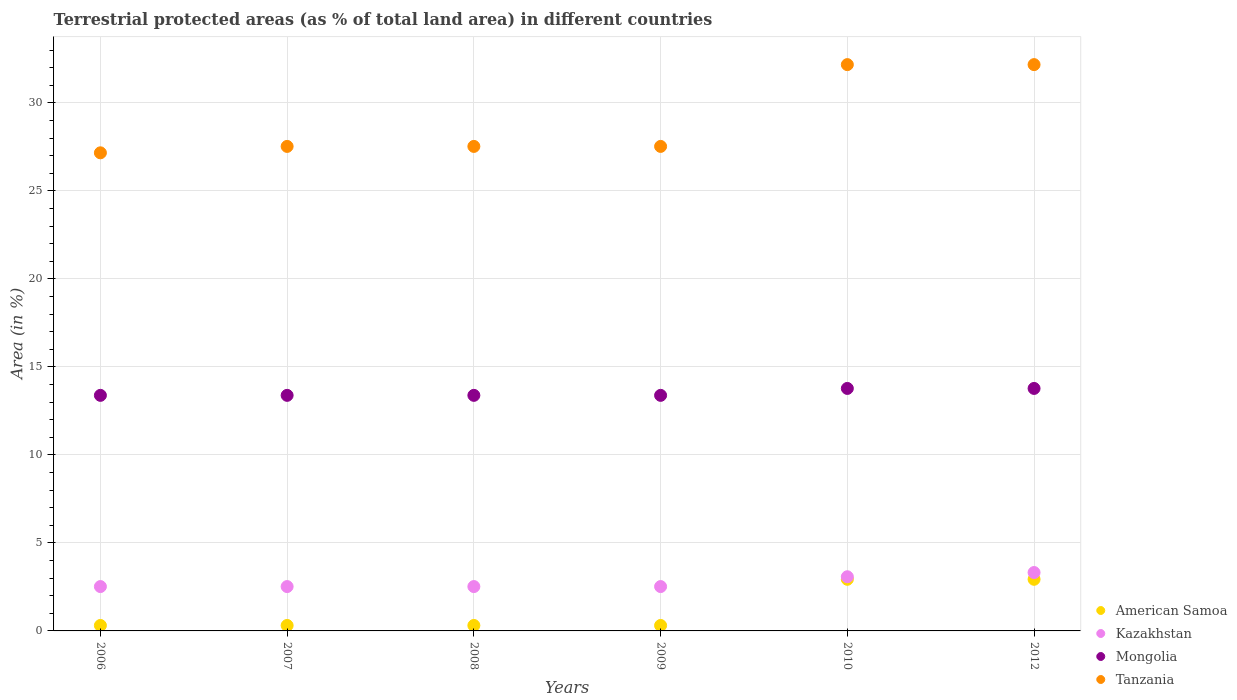How many different coloured dotlines are there?
Offer a very short reply. 4. Is the number of dotlines equal to the number of legend labels?
Your response must be concise. Yes. What is the percentage of terrestrial protected land in American Samoa in 2010?
Offer a terse response. 2.93. Across all years, what is the maximum percentage of terrestrial protected land in Mongolia?
Make the answer very short. 13.78. Across all years, what is the minimum percentage of terrestrial protected land in Kazakhstan?
Make the answer very short. 2.52. In which year was the percentage of terrestrial protected land in Tanzania maximum?
Offer a terse response. 2010. In which year was the percentage of terrestrial protected land in Mongolia minimum?
Make the answer very short. 2006. What is the total percentage of terrestrial protected land in Tanzania in the graph?
Keep it short and to the point. 174.13. What is the difference between the percentage of terrestrial protected land in American Samoa in 2006 and that in 2007?
Your answer should be compact. 0. What is the difference between the percentage of terrestrial protected land in American Samoa in 2012 and the percentage of terrestrial protected land in Mongolia in 2009?
Offer a very short reply. -10.45. What is the average percentage of terrestrial protected land in Mongolia per year?
Offer a terse response. 13.52. In the year 2008, what is the difference between the percentage of terrestrial protected land in Kazakhstan and percentage of terrestrial protected land in Mongolia?
Keep it short and to the point. -10.87. In how many years, is the percentage of terrestrial protected land in Kazakhstan greater than 3 %?
Ensure brevity in your answer.  2. Is the difference between the percentage of terrestrial protected land in Kazakhstan in 2008 and 2010 greater than the difference between the percentage of terrestrial protected land in Mongolia in 2008 and 2010?
Provide a succinct answer. No. What is the difference between the highest and the second highest percentage of terrestrial protected land in Kazakhstan?
Your response must be concise. 0.24. What is the difference between the highest and the lowest percentage of terrestrial protected land in American Samoa?
Offer a terse response. 2.62. In how many years, is the percentage of terrestrial protected land in Tanzania greater than the average percentage of terrestrial protected land in Tanzania taken over all years?
Your response must be concise. 2. Is it the case that in every year, the sum of the percentage of terrestrial protected land in Mongolia and percentage of terrestrial protected land in American Samoa  is greater than the sum of percentage of terrestrial protected land in Kazakhstan and percentage of terrestrial protected land in Tanzania?
Provide a short and direct response. No. Is it the case that in every year, the sum of the percentage of terrestrial protected land in Tanzania and percentage of terrestrial protected land in Mongolia  is greater than the percentage of terrestrial protected land in American Samoa?
Offer a terse response. Yes. Does the percentage of terrestrial protected land in American Samoa monotonically increase over the years?
Your answer should be very brief. No. How many years are there in the graph?
Your answer should be compact. 6. Does the graph contain grids?
Your answer should be very brief. Yes. Where does the legend appear in the graph?
Make the answer very short. Bottom right. What is the title of the graph?
Make the answer very short. Terrestrial protected areas (as % of total land area) in different countries. Does "Fragile and conflict affected situations" appear as one of the legend labels in the graph?
Ensure brevity in your answer.  No. What is the label or title of the Y-axis?
Ensure brevity in your answer.  Area (in %). What is the Area (in %) of American Samoa in 2006?
Your answer should be very brief. 0.31. What is the Area (in %) in Kazakhstan in 2006?
Make the answer very short. 2.52. What is the Area (in %) in Mongolia in 2006?
Keep it short and to the point. 13.39. What is the Area (in %) of Tanzania in 2006?
Your answer should be very brief. 27.17. What is the Area (in %) in American Samoa in 2007?
Ensure brevity in your answer.  0.31. What is the Area (in %) of Kazakhstan in 2007?
Offer a terse response. 2.52. What is the Area (in %) in Mongolia in 2007?
Offer a very short reply. 13.39. What is the Area (in %) in Tanzania in 2007?
Keep it short and to the point. 27.53. What is the Area (in %) of American Samoa in 2008?
Make the answer very short. 0.31. What is the Area (in %) of Kazakhstan in 2008?
Ensure brevity in your answer.  2.52. What is the Area (in %) of Mongolia in 2008?
Keep it short and to the point. 13.39. What is the Area (in %) in Tanzania in 2008?
Make the answer very short. 27.53. What is the Area (in %) in American Samoa in 2009?
Your answer should be compact. 0.31. What is the Area (in %) of Kazakhstan in 2009?
Offer a terse response. 2.52. What is the Area (in %) of Mongolia in 2009?
Ensure brevity in your answer.  13.39. What is the Area (in %) in Tanzania in 2009?
Your answer should be very brief. 27.53. What is the Area (in %) of American Samoa in 2010?
Keep it short and to the point. 2.93. What is the Area (in %) in Kazakhstan in 2010?
Keep it short and to the point. 3.08. What is the Area (in %) in Mongolia in 2010?
Offer a very short reply. 13.78. What is the Area (in %) in Tanzania in 2010?
Your response must be concise. 32.18. What is the Area (in %) in American Samoa in 2012?
Ensure brevity in your answer.  2.93. What is the Area (in %) in Kazakhstan in 2012?
Keep it short and to the point. 3.32. What is the Area (in %) in Mongolia in 2012?
Ensure brevity in your answer.  13.78. What is the Area (in %) of Tanzania in 2012?
Your answer should be compact. 32.18. Across all years, what is the maximum Area (in %) in American Samoa?
Offer a very short reply. 2.93. Across all years, what is the maximum Area (in %) in Kazakhstan?
Give a very brief answer. 3.32. Across all years, what is the maximum Area (in %) in Mongolia?
Keep it short and to the point. 13.78. Across all years, what is the maximum Area (in %) in Tanzania?
Provide a short and direct response. 32.18. Across all years, what is the minimum Area (in %) of American Samoa?
Your answer should be very brief. 0.31. Across all years, what is the minimum Area (in %) in Kazakhstan?
Your response must be concise. 2.52. Across all years, what is the minimum Area (in %) in Mongolia?
Your answer should be compact. 13.39. Across all years, what is the minimum Area (in %) of Tanzania?
Ensure brevity in your answer.  27.17. What is the total Area (in %) of American Samoa in the graph?
Provide a short and direct response. 7.11. What is the total Area (in %) of Kazakhstan in the graph?
Offer a very short reply. 16.48. What is the total Area (in %) of Mongolia in the graph?
Give a very brief answer. 81.1. What is the total Area (in %) in Tanzania in the graph?
Make the answer very short. 174.13. What is the difference between the Area (in %) of American Samoa in 2006 and that in 2007?
Provide a succinct answer. 0. What is the difference between the Area (in %) in Mongolia in 2006 and that in 2007?
Your response must be concise. 0. What is the difference between the Area (in %) of Tanzania in 2006 and that in 2007?
Offer a very short reply. -0.36. What is the difference between the Area (in %) in American Samoa in 2006 and that in 2008?
Ensure brevity in your answer.  0. What is the difference between the Area (in %) in Mongolia in 2006 and that in 2008?
Offer a terse response. 0. What is the difference between the Area (in %) of Tanzania in 2006 and that in 2008?
Offer a terse response. -0.36. What is the difference between the Area (in %) in Kazakhstan in 2006 and that in 2009?
Give a very brief answer. 0. What is the difference between the Area (in %) in Mongolia in 2006 and that in 2009?
Ensure brevity in your answer.  0. What is the difference between the Area (in %) of Tanzania in 2006 and that in 2009?
Provide a succinct answer. -0.36. What is the difference between the Area (in %) in American Samoa in 2006 and that in 2010?
Provide a succinct answer. -2.62. What is the difference between the Area (in %) of Kazakhstan in 2006 and that in 2010?
Make the answer very short. -0.56. What is the difference between the Area (in %) in Mongolia in 2006 and that in 2010?
Make the answer very short. -0.39. What is the difference between the Area (in %) in Tanzania in 2006 and that in 2010?
Offer a very short reply. -5.01. What is the difference between the Area (in %) of American Samoa in 2006 and that in 2012?
Your answer should be compact. -2.62. What is the difference between the Area (in %) in Kazakhstan in 2006 and that in 2012?
Your response must be concise. -0.8. What is the difference between the Area (in %) of Mongolia in 2006 and that in 2012?
Your answer should be compact. -0.39. What is the difference between the Area (in %) of Tanzania in 2006 and that in 2012?
Provide a succinct answer. -5.01. What is the difference between the Area (in %) in Kazakhstan in 2007 and that in 2008?
Your response must be concise. 0. What is the difference between the Area (in %) in Kazakhstan in 2007 and that in 2009?
Keep it short and to the point. 0. What is the difference between the Area (in %) of Mongolia in 2007 and that in 2009?
Give a very brief answer. 0. What is the difference between the Area (in %) in American Samoa in 2007 and that in 2010?
Provide a short and direct response. -2.62. What is the difference between the Area (in %) in Kazakhstan in 2007 and that in 2010?
Your answer should be compact. -0.56. What is the difference between the Area (in %) in Mongolia in 2007 and that in 2010?
Your response must be concise. -0.39. What is the difference between the Area (in %) of Tanzania in 2007 and that in 2010?
Provide a short and direct response. -4.65. What is the difference between the Area (in %) in American Samoa in 2007 and that in 2012?
Your answer should be very brief. -2.62. What is the difference between the Area (in %) in Kazakhstan in 2007 and that in 2012?
Your answer should be very brief. -0.8. What is the difference between the Area (in %) in Mongolia in 2007 and that in 2012?
Your answer should be very brief. -0.39. What is the difference between the Area (in %) in Tanzania in 2007 and that in 2012?
Give a very brief answer. -4.65. What is the difference between the Area (in %) in American Samoa in 2008 and that in 2009?
Offer a very short reply. 0. What is the difference between the Area (in %) of American Samoa in 2008 and that in 2010?
Offer a terse response. -2.62. What is the difference between the Area (in %) of Kazakhstan in 2008 and that in 2010?
Ensure brevity in your answer.  -0.56. What is the difference between the Area (in %) in Mongolia in 2008 and that in 2010?
Offer a very short reply. -0.39. What is the difference between the Area (in %) of Tanzania in 2008 and that in 2010?
Ensure brevity in your answer.  -4.65. What is the difference between the Area (in %) of American Samoa in 2008 and that in 2012?
Give a very brief answer. -2.62. What is the difference between the Area (in %) of Kazakhstan in 2008 and that in 2012?
Give a very brief answer. -0.8. What is the difference between the Area (in %) in Mongolia in 2008 and that in 2012?
Ensure brevity in your answer.  -0.39. What is the difference between the Area (in %) of Tanzania in 2008 and that in 2012?
Your answer should be very brief. -4.65. What is the difference between the Area (in %) of American Samoa in 2009 and that in 2010?
Your answer should be compact. -2.62. What is the difference between the Area (in %) of Kazakhstan in 2009 and that in 2010?
Your answer should be compact. -0.56. What is the difference between the Area (in %) in Mongolia in 2009 and that in 2010?
Offer a terse response. -0.39. What is the difference between the Area (in %) in Tanzania in 2009 and that in 2010?
Offer a very short reply. -4.65. What is the difference between the Area (in %) in American Samoa in 2009 and that in 2012?
Your answer should be compact. -2.62. What is the difference between the Area (in %) of Kazakhstan in 2009 and that in 2012?
Provide a succinct answer. -0.8. What is the difference between the Area (in %) in Mongolia in 2009 and that in 2012?
Your response must be concise. -0.39. What is the difference between the Area (in %) in Tanzania in 2009 and that in 2012?
Offer a very short reply. -4.65. What is the difference between the Area (in %) of Kazakhstan in 2010 and that in 2012?
Keep it short and to the point. -0.24. What is the difference between the Area (in %) in Mongolia in 2010 and that in 2012?
Make the answer very short. 0. What is the difference between the Area (in %) in Tanzania in 2010 and that in 2012?
Provide a short and direct response. 0. What is the difference between the Area (in %) in American Samoa in 2006 and the Area (in %) in Kazakhstan in 2007?
Your answer should be compact. -2.21. What is the difference between the Area (in %) in American Samoa in 2006 and the Area (in %) in Mongolia in 2007?
Provide a succinct answer. -13.08. What is the difference between the Area (in %) of American Samoa in 2006 and the Area (in %) of Tanzania in 2007?
Provide a short and direct response. -27.22. What is the difference between the Area (in %) of Kazakhstan in 2006 and the Area (in %) of Mongolia in 2007?
Provide a succinct answer. -10.87. What is the difference between the Area (in %) of Kazakhstan in 2006 and the Area (in %) of Tanzania in 2007?
Your answer should be very brief. -25.01. What is the difference between the Area (in %) in Mongolia in 2006 and the Area (in %) in Tanzania in 2007?
Your answer should be very brief. -14.15. What is the difference between the Area (in %) in American Samoa in 2006 and the Area (in %) in Kazakhstan in 2008?
Offer a terse response. -2.21. What is the difference between the Area (in %) in American Samoa in 2006 and the Area (in %) in Mongolia in 2008?
Provide a succinct answer. -13.08. What is the difference between the Area (in %) of American Samoa in 2006 and the Area (in %) of Tanzania in 2008?
Your answer should be compact. -27.22. What is the difference between the Area (in %) in Kazakhstan in 2006 and the Area (in %) in Mongolia in 2008?
Offer a very short reply. -10.87. What is the difference between the Area (in %) of Kazakhstan in 2006 and the Area (in %) of Tanzania in 2008?
Give a very brief answer. -25.01. What is the difference between the Area (in %) in Mongolia in 2006 and the Area (in %) in Tanzania in 2008?
Offer a terse response. -14.15. What is the difference between the Area (in %) of American Samoa in 2006 and the Area (in %) of Kazakhstan in 2009?
Keep it short and to the point. -2.21. What is the difference between the Area (in %) of American Samoa in 2006 and the Area (in %) of Mongolia in 2009?
Offer a terse response. -13.08. What is the difference between the Area (in %) of American Samoa in 2006 and the Area (in %) of Tanzania in 2009?
Provide a short and direct response. -27.22. What is the difference between the Area (in %) of Kazakhstan in 2006 and the Area (in %) of Mongolia in 2009?
Offer a terse response. -10.87. What is the difference between the Area (in %) in Kazakhstan in 2006 and the Area (in %) in Tanzania in 2009?
Ensure brevity in your answer.  -25.01. What is the difference between the Area (in %) in Mongolia in 2006 and the Area (in %) in Tanzania in 2009?
Your answer should be compact. -14.15. What is the difference between the Area (in %) of American Samoa in 2006 and the Area (in %) of Kazakhstan in 2010?
Offer a very short reply. -2.77. What is the difference between the Area (in %) of American Samoa in 2006 and the Area (in %) of Mongolia in 2010?
Your response must be concise. -13.47. What is the difference between the Area (in %) of American Samoa in 2006 and the Area (in %) of Tanzania in 2010?
Give a very brief answer. -31.87. What is the difference between the Area (in %) of Kazakhstan in 2006 and the Area (in %) of Mongolia in 2010?
Give a very brief answer. -11.26. What is the difference between the Area (in %) in Kazakhstan in 2006 and the Area (in %) in Tanzania in 2010?
Your answer should be compact. -29.66. What is the difference between the Area (in %) of Mongolia in 2006 and the Area (in %) of Tanzania in 2010?
Your answer should be compact. -18.79. What is the difference between the Area (in %) of American Samoa in 2006 and the Area (in %) of Kazakhstan in 2012?
Offer a very short reply. -3.01. What is the difference between the Area (in %) of American Samoa in 2006 and the Area (in %) of Mongolia in 2012?
Offer a very short reply. -13.47. What is the difference between the Area (in %) in American Samoa in 2006 and the Area (in %) in Tanzania in 2012?
Your response must be concise. -31.87. What is the difference between the Area (in %) of Kazakhstan in 2006 and the Area (in %) of Mongolia in 2012?
Offer a very short reply. -11.26. What is the difference between the Area (in %) in Kazakhstan in 2006 and the Area (in %) in Tanzania in 2012?
Offer a terse response. -29.66. What is the difference between the Area (in %) in Mongolia in 2006 and the Area (in %) in Tanzania in 2012?
Offer a very short reply. -18.79. What is the difference between the Area (in %) in American Samoa in 2007 and the Area (in %) in Kazakhstan in 2008?
Make the answer very short. -2.21. What is the difference between the Area (in %) of American Samoa in 2007 and the Area (in %) of Mongolia in 2008?
Keep it short and to the point. -13.08. What is the difference between the Area (in %) of American Samoa in 2007 and the Area (in %) of Tanzania in 2008?
Make the answer very short. -27.22. What is the difference between the Area (in %) in Kazakhstan in 2007 and the Area (in %) in Mongolia in 2008?
Provide a short and direct response. -10.87. What is the difference between the Area (in %) in Kazakhstan in 2007 and the Area (in %) in Tanzania in 2008?
Offer a very short reply. -25.01. What is the difference between the Area (in %) of Mongolia in 2007 and the Area (in %) of Tanzania in 2008?
Make the answer very short. -14.15. What is the difference between the Area (in %) in American Samoa in 2007 and the Area (in %) in Kazakhstan in 2009?
Your response must be concise. -2.21. What is the difference between the Area (in %) in American Samoa in 2007 and the Area (in %) in Mongolia in 2009?
Your response must be concise. -13.08. What is the difference between the Area (in %) in American Samoa in 2007 and the Area (in %) in Tanzania in 2009?
Offer a very short reply. -27.22. What is the difference between the Area (in %) in Kazakhstan in 2007 and the Area (in %) in Mongolia in 2009?
Offer a terse response. -10.87. What is the difference between the Area (in %) in Kazakhstan in 2007 and the Area (in %) in Tanzania in 2009?
Offer a very short reply. -25.01. What is the difference between the Area (in %) of Mongolia in 2007 and the Area (in %) of Tanzania in 2009?
Give a very brief answer. -14.15. What is the difference between the Area (in %) in American Samoa in 2007 and the Area (in %) in Kazakhstan in 2010?
Give a very brief answer. -2.77. What is the difference between the Area (in %) of American Samoa in 2007 and the Area (in %) of Mongolia in 2010?
Provide a succinct answer. -13.47. What is the difference between the Area (in %) in American Samoa in 2007 and the Area (in %) in Tanzania in 2010?
Provide a succinct answer. -31.87. What is the difference between the Area (in %) in Kazakhstan in 2007 and the Area (in %) in Mongolia in 2010?
Offer a very short reply. -11.26. What is the difference between the Area (in %) in Kazakhstan in 2007 and the Area (in %) in Tanzania in 2010?
Provide a succinct answer. -29.66. What is the difference between the Area (in %) in Mongolia in 2007 and the Area (in %) in Tanzania in 2010?
Offer a terse response. -18.79. What is the difference between the Area (in %) in American Samoa in 2007 and the Area (in %) in Kazakhstan in 2012?
Ensure brevity in your answer.  -3.01. What is the difference between the Area (in %) of American Samoa in 2007 and the Area (in %) of Mongolia in 2012?
Provide a short and direct response. -13.47. What is the difference between the Area (in %) of American Samoa in 2007 and the Area (in %) of Tanzania in 2012?
Offer a very short reply. -31.87. What is the difference between the Area (in %) of Kazakhstan in 2007 and the Area (in %) of Mongolia in 2012?
Your answer should be compact. -11.26. What is the difference between the Area (in %) in Kazakhstan in 2007 and the Area (in %) in Tanzania in 2012?
Offer a terse response. -29.66. What is the difference between the Area (in %) in Mongolia in 2007 and the Area (in %) in Tanzania in 2012?
Give a very brief answer. -18.79. What is the difference between the Area (in %) in American Samoa in 2008 and the Area (in %) in Kazakhstan in 2009?
Ensure brevity in your answer.  -2.21. What is the difference between the Area (in %) of American Samoa in 2008 and the Area (in %) of Mongolia in 2009?
Make the answer very short. -13.08. What is the difference between the Area (in %) of American Samoa in 2008 and the Area (in %) of Tanzania in 2009?
Your answer should be very brief. -27.22. What is the difference between the Area (in %) of Kazakhstan in 2008 and the Area (in %) of Mongolia in 2009?
Make the answer very short. -10.87. What is the difference between the Area (in %) of Kazakhstan in 2008 and the Area (in %) of Tanzania in 2009?
Ensure brevity in your answer.  -25.01. What is the difference between the Area (in %) in Mongolia in 2008 and the Area (in %) in Tanzania in 2009?
Give a very brief answer. -14.15. What is the difference between the Area (in %) in American Samoa in 2008 and the Area (in %) in Kazakhstan in 2010?
Offer a very short reply. -2.77. What is the difference between the Area (in %) of American Samoa in 2008 and the Area (in %) of Mongolia in 2010?
Ensure brevity in your answer.  -13.47. What is the difference between the Area (in %) in American Samoa in 2008 and the Area (in %) in Tanzania in 2010?
Give a very brief answer. -31.87. What is the difference between the Area (in %) in Kazakhstan in 2008 and the Area (in %) in Mongolia in 2010?
Keep it short and to the point. -11.26. What is the difference between the Area (in %) of Kazakhstan in 2008 and the Area (in %) of Tanzania in 2010?
Your answer should be very brief. -29.66. What is the difference between the Area (in %) in Mongolia in 2008 and the Area (in %) in Tanzania in 2010?
Provide a succinct answer. -18.79. What is the difference between the Area (in %) in American Samoa in 2008 and the Area (in %) in Kazakhstan in 2012?
Give a very brief answer. -3.01. What is the difference between the Area (in %) in American Samoa in 2008 and the Area (in %) in Mongolia in 2012?
Give a very brief answer. -13.47. What is the difference between the Area (in %) in American Samoa in 2008 and the Area (in %) in Tanzania in 2012?
Offer a very short reply. -31.87. What is the difference between the Area (in %) in Kazakhstan in 2008 and the Area (in %) in Mongolia in 2012?
Give a very brief answer. -11.26. What is the difference between the Area (in %) of Kazakhstan in 2008 and the Area (in %) of Tanzania in 2012?
Your answer should be compact. -29.66. What is the difference between the Area (in %) in Mongolia in 2008 and the Area (in %) in Tanzania in 2012?
Provide a short and direct response. -18.79. What is the difference between the Area (in %) of American Samoa in 2009 and the Area (in %) of Kazakhstan in 2010?
Your response must be concise. -2.77. What is the difference between the Area (in %) of American Samoa in 2009 and the Area (in %) of Mongolia in 2010?
Make the answer very short. -13.47. What is the difference between the Area (in %) in American Samoa in 2009 and the Area (in %) in Tanzania in 2010?
Provide a succinct answer. -31.87. What is the difference between the Area (in %) in Kazakhstan in 2009 and the Area (in %) in Mongolia in 2010?
Provide a succinct answer. -11.26. What is the difference between the Area (in %) of Kazakhstan in 2009 and the Area (in %) of Tanzania in 2010?
Offer a very short reply. -29.66. What is the difference between the Area (in %) in Mongolia in 2009 and the Area (in %) in Tanzania in 2010?
Give a very brief answer. -18.79. What is the difference between the Area (in %) of American Samoa in 2009 and the Area (in %) of Kazakhstan in 2012?
Provide a succinct answer. -3.01. What is the difference between the Area (in %) in American Samoa in 2009 and the Area (in %) in Mongolia in 2012?
Offer a very short reply. -13.47. What is the difference between the Area (in %) of American Samoa in 2009 and the Area (in %) of Tanzania in 2012?
Provide a short and direct response. -31.87. What is the difference between the Area (in %) of Kazakhstan in 2009 and the Area (in %) of Mongolia in 2012?
Give a very brief answer. -11.26. What is the difference between the Area (in %) in Kazakhstan in 2009 and the Area (in %) in Tanzania in 2012?
Provide a short and direct response. -29.66. What is the difference between the Area (in %) in Mongolia in 2009 and the Area (in %) in Tanzania in 2012?
Your response must be concise. -18.79. What is the difference between the Area (in %) of American Samoa in 2010 and the Area (in %) of Kazakhstan in 2012?
Your response must be concise. -0.38. What is the difference between the Area (in %) of American Samoa in 2010 and the Area (in %) of Mongolia in 2012?
Keep it short and to the point. -10.85. What is the difference between the Area (in %) of American Samoa in 2010 and the Area (in %) of Tanzania in 2012?
Your answer should be compact. -29.25. What is the difference between the Area (in %) in Kazakhstan in 2010 and the Area (in %) in Mongolia in 2012?
Your response must be concise. -10.7. What is the difference between the Area (in %) of Kazakhstan in 2010 and the Area (in %) of Tanzania in 2012?
Provide a short and direct response. -29.1. What is the difference between the Area (in %) of Mongolia in 2010 and the Area (in %) of Tanzania in 2012?
Provide a short and direct response. -18.4. What is the average Area (in %) of American Samoa per year?
Your response must be concise. 1.18. What is the average Area (in %) of Kazakhstan per year?
Your answer should be very brief. 2.75. What is the average Area (in %) in Mongolia per year?
Offer a terse response. 13.52. What is the average Area (in %) in Tanzania per year?
Keep it short and to the point. 29.02. In the year 2006, what is the difference between the Area (in %) of American Samoa and Area (in %) of Kazakhstan?
Ensure brevity in your answer.  -2.21. In the year 2006, what is the difference between the Area (in %) in American Samoa and Area (in %) in Mongolia?
Ensure brevity in your answer.  -13.08. In the year 2006, what is the difference between the Area (in %) of American Samoa and Area (in %) of Tanzania?
Your answer should be very brief. -26.86. In the year 2006, what is the difference between the Area (in %) in Kazakhstan and Area (in %) in Mongolia?
Your answer should be very brief. -10.87. In the year 2006, what is the difference between the Area (in %) of Kazakhstan and Area (in %) of Tanzania?
Provide a succinct answer. -24.65. In the year 2006, what is the difference between the Area (in %) of Mongolia and Area (in %) of Tanzania?
Make the answer very short. -13.78. In the year 2007, what is the difference between the Area (in %) of American Samoa and Area (in %) of Kazakhstan?
Your answer should be compact. -2.21. In the year 2007, what is the difference between the Area (in %) in American Samoa and Area (in %) in Mongolia?
Offer a very short reply. -13.08. In the year 2007, what is the difference between the Area (in %) in American Samoa and Area (in %) in Tanzania?
Your answer should be very brief. -27.22. In the year 2007, what is the difference between the Area (in %) in Kazakhstan and Area (in %) in Mongolia?
Make the answer very short. -10.87. In the year 2007, what is the difference between the Area (in %) of Kazakhstan and Area (in %) of Tanzania?
Offer a terse response. -25.01. In the year 2007, what is the difference between the Area (in %) of Mongolia and Area (in %) of Tanzania?
Your answer should be compact. -14.15. In the year 2008, what is the difference between the Area (in %) of American Samoa and Area (in %) of Kazakhstan?
Provide a short and direct response. -2.21. In the year 2008, what is the difference between the Area (in %) in American Samoa and Area (in %) in Mongolia?
Your answer should be very brief. -13.08. In the year 2008, what is the difference between the Area (in %) of American Samoa and Area (in %) of Tanzania?
Offer a terse response. -27.22. In the year 2008, what is the difference between the Area (in %) of Kazakhstan and Area (in %) of Mongolia?
Your answer should be very brief. -10.87. In the year 2008, what is the difference between the Area (in %) of Kazakhstan and Area (in %) of Tanzania?
Offer a terse response. -25.01. In the year 2008, what is the difference between the Area (in %) of Mongolia and Area (in %) of Tanzania?
Your response must be concise. -14.15. In the year 2009, what is the difference between the Area (in %) of American Samoa and Area (in %) of Kazakhstan?
Offer a terse response. -2.21. In the year 2009, what is the difference between the Area (in %) of American Samoa and Area (in %) of Mongolia?
Your answer should be compact. -13.08. In the year 2009, what is the difference between the Area (in %) of American Samoa and Area (in %) of Tanzania?
Your answer should be very brief. -27.22. In the year 2009, what is the difference between the Area (in %) in Kazakhstan and Area (in %) in Mongolia?
Keep it short and to the point. -10.87. In the year 2009, what is the difference between the Area (in %) in Kazakhstan and Area (in %) in Tanzania?
Provide a succinct answer. -25.01. In the year 2009, what is the difference between the Area (in %) in Mongolia and Area (in %) in Tanzania?
Provide a succinct answer. -14.15. In the year 2010, what is the difference between the Area (in %) of American Samoa and Area (in %) of Kazakhstan?
Your response must be concise. -0.14. In the year 2010, what is the difference between the Area (in %) of American Samoa and Area (in %) of Mongolia?
Give a very brief answer. -10.85. In the year 2010, what is the difference between the Area (in %) of American Samoa and Area (in %) of Tanzania?
Ensure brevity in your answer.  -29.25. In the year 2010, what is the difference between the Area (in %) of Kazakhstan and Area (in %) of Mongolia?
Your response must be concise. -10.7. In the year 2010, what is the difference between the Area (in %) in Kazakhstan and Area (in %) in Tanzania?
Provide a short and direct response. -29.1. In the year 2010, what is the difference between the Area (in %) in Mongolia and Area (in %) in Tanzania?
Provide a short and direct response. -18.4. In the year 2012, what is the difference between the Area (in %) of American Samoa and Area (in %) of Kazakhstan?
Offer a terse response. -0.38. In the year 2012, what is the difference between the Area (in %) of American Samoa and Area (in %) of Mongolia?
Ensure brevity in your answer.  -10.85. In the year 2012, what is the difference between the Area (in %) of American Samoa and Area (in %) of Tanzania?
Your response must be concise. -29.25. In the year 2012, what is the difference between the Area (in %) of Kazakhstan and Area (in %) of Mongolia?
Your response must be concise. -10.46. In the year 2012, what is the difference between the Area (in %) in Kazakhstan and Area (in %) in Tanzania?
Keep it short and to the point. -28.86. In the year 2012, what is the difference between the Area (in %) in Mongolia and Area (in %) in Tanzania?
Offer a very short reply. -18.4. What is the ratio of the Area (in %) of Mongolia in 2006 to that in 2007?
Your response must be concise. 1. What is the ratio of the Area (in %) in Tanzania in 2006 to that in 2007?
Your answer should be very brief. 0.99. What is the ratio of the Area (in %) of Kazakhstan in 2006 to that in 2008?
Provide a succinct answer. 1. What is the ratio of the Area (in %) in American Samoa in 2006 to that in 2010?
Your answer should be very brief. 0.11. What is the ratio of the Area (in %) in Kazakhstan in 2006 to that in 2010?
Provide a succinct answer. 0.82. What is the ratio of the Area (in %) in Mongolia in 2006 to that in 2010?
Provide a succinct answer. 0.97. What is the ratio of the Area (in %) in Tanzania in 2006 to that in 2010?
Your answer should be very brief. 0.84. What is the ratio of the Area (in %) in American Samoa in 2006 to that in 2012?
Provide a succinct answer. 0.11. What is the ratio of the Area (in %) in Kazakhstan in 2006 to that in 2012?
Keep it short and to the point. 0.76. What is the ratio of the Area (in %) of Mongolia in 2006 to that in 2012?
Offer a terse response. 0.97. What is the ratio of the Area (in %) in Tanzania in 2006 to that in 2012?
Keep it short and to the point. 0.84. What is the ratio of the Area (in %) in American Samoa in 2007 to that in 2008?
Keep it short and to the point. 1. What is the ratio of the Area (in %) of Mongolia in 2007 to that in 2008?
Give a very brief answer. 1. What is the ratio of the Area (in %) of Tanzania in 2007 to that in 2008?
Keep it short and to the point. 1. What is the ratio of the Area (in %) in Kazakhstan in 2007 to that in 2009?
Offer a terse response. 1. What is the ratio of the Area (in %) in Mongolia in 2007 to that in 2009?
Keep it short and to the point. 1. What is the ratio of the Area (in %) in American Samoa in 2007 to that in 2010?
Ensure brevity in your answer.  0.11. What is the ratio of the Area (in %) in Kazakhstan in 2007 to that in 2010?
Ensure brevity in your answer.  0.82. What is the ratio of the Area (in %) of Mongolia in 2007 to that in 2010?
Provide a succinct answer. 0.97. What is the ratio of the Area (in %) in Tanzania in 2007 to that in 2010?
Keep it short and to the point. 0.86. What is the ratio of the Area (in %) in American Samoa in 2007 to that in 2012?
Your answer should be very brief. 0.11. What is the ratio of the Area (in %) in Kazakhstan in 2007 to that in 2012?
Provide a succinct answer. 0.76. What is the ratio of the Area (in %) in Mongolia in 2007 to that in 2012?
Offer a very short reply. 0.97. What is the ratio of the Area (in %) in Tanzania in 2007 to that in 2012?
Offer a terse response. 0.86. What is the ratio of the Area (in %) of Kazakhstan in 2008 to that in 2009?
Your answer should be compact. 1. What is the ratio of the Area (in %) of Mongolia in 2008 to that in 2009?
Your response must be concise. 1. What is the ratio of the Area (in %) of American Samoa in 2008 to that in 2010?
Keep it short and to the point. 0.11. What is the ratio of the Area (in %) of Kazakhstan in 2008 to that in 2010?
Provide a succinct answer. 0.82. What is the ratio of the Area (in %) in Mongolia in 2008 to that in 2010?
Give a very brief answer. 0.97. What is the ratio of the Area (in %) in Tanzania in 2008 to that in 2010?
Your answer should be compact. 0.86. What is the ratio of the Area (in %) of American Samoa in 2008 to that in 2012?
Offer a terse response. 0.11. What is the ratio of the Area (in %) in Kazakhstan in 2008 to that in 2012?
Your answer should be very brief. 0.76. What is the ratio of the Area (in %) of Mongolia in 2008 to that in 2012?
Offer a very short reply. 0.97. What is the ratio of the Area (in %) in Tanzania in 2008 to that in 2012?
Offer a very short reply. 0.86. What is the ratio of the Area (in %) in American Samoa in 2009 to that in 2010?
Offer a very short reply. 0.11. What is the ratio of the Area (in %) in Kazakhstan in 2009 to that in 2010?
Make the answer very short. 0.82. What is the ratio of the Area (in %) of Mongolia in 2009 to that in 2010?
Your response must be concise. 0.97. What is the ratio of the Area (in %) in Tanzania in 2009 to that in 2010?
Provide a succinct answer. 0.86. What is the ratio of the Area (in %) in American Samoa in 2009 to that in 2012?
Provide a short and direct response. 0.11. What is the ratio of the Area (in %) of Kazakhstan in 2009 to that in 2012?
Make the answer very short. 0.76. What is the ratio of the Area (in %) in Mongolia in 2009 to that in 2012?
Keep it short and to the point. 0.97. What is the ratio of the Area (in %) of Tanzania in 2009 to that in 2012?
Give a very brief answer. 0.86. What is the ratio of the Area (in %) of Kazakhstan in 2010 to that in 2012?
Ensure brevity in your answer.  0.93. What is the difference between the highest and the second highest Area (in %) of Kazakhstan?
Your response must be concise. 0.24. What is the difference between the highest and the second highest Area (in %) in Mongolia?
Your response must be concise. 0. What is the difference between the highest and the lowest Area (in %) of American Samoa?
Provide a succinct answer. 2.62. What is the difference between the highest and the lowest Area (in %) of Kazakhstan?
Offer a very short reply. 0.8. What is the difference between the highest and the lowest Area (in %) in Mongolia?
Give a very brief answer. 0.39. What is the difference between the highest and the lowest Area (in %) in Tanzania?
Offer a terse response. 5.01. 